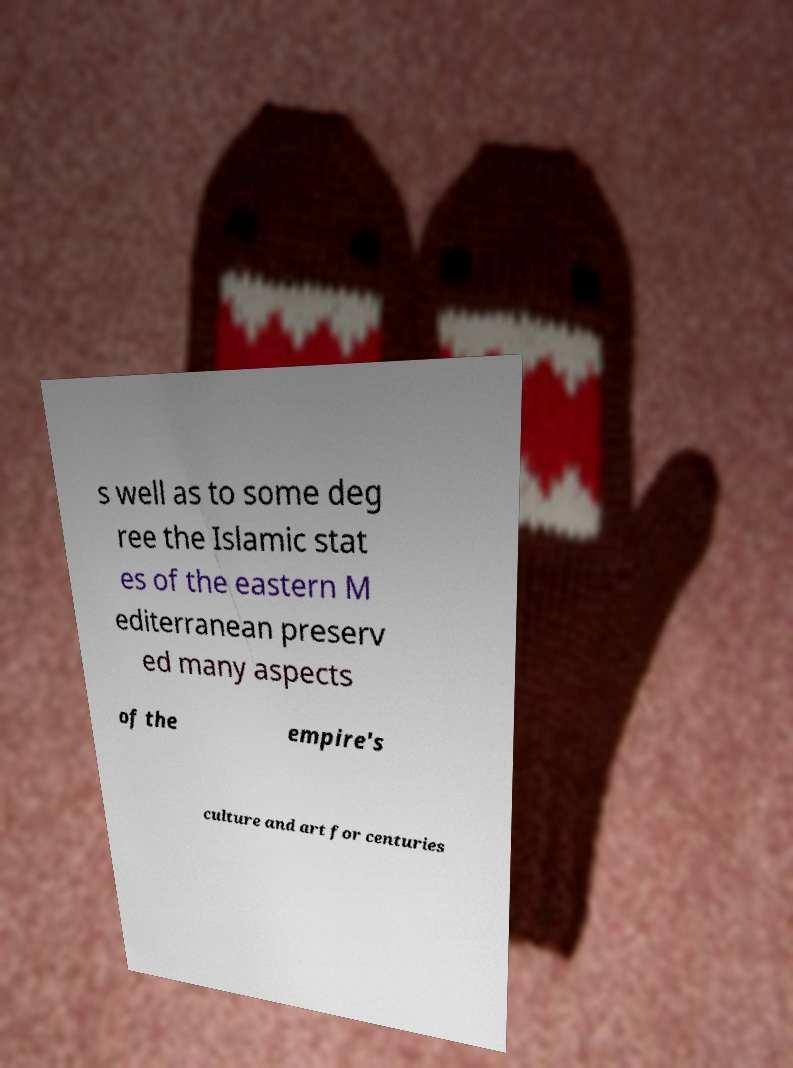There's text embedded in this image that I need extracted. Can you transcribe it verbatim? s well as to some deg ree the Islamic stat es of the eastern M editerranean preserv ed many aspects of the empire's culture and art for centuries 